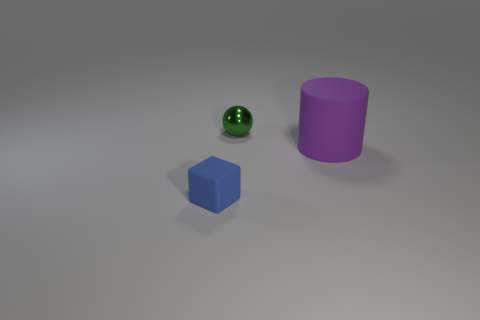Are there any big cylinders to the left of the object that is behind the rubber cylinder?
Your answer should be compact. No. What is the material of the object that is both to the left of the big object and on the right side of the small matte block?
Your answer should be very brief. Metal. What is the color of the rubber object that is in front of the matte object that is on the right side of the thing that is in front of the purple thing?
Give a very brief answer. Blue. What color is the other thing that is the same size as the blue thing?
Your answer should be very brief. Green. What material is the thing that is in front of the purple rubber cylinder in front of the green sphere?
Make the answer very short. Rubber. How many things are both in front of the purple matte cylinder and behind the big purple matte cylinder?
Ensure brevity in your answer.  0. How many other objects are the same size as the metal object?
Provide a succinct answer. 1. Are there any purple cylinders behind the small matte cube?
Ensure brevity in your answer.  Yes. Is there any other thing that is the same shape as the tiny green object?
Your answer should be compact. No. What material is the tiny object left of the tiny green metallic sphere?
Offer a terse response. Rubber. 